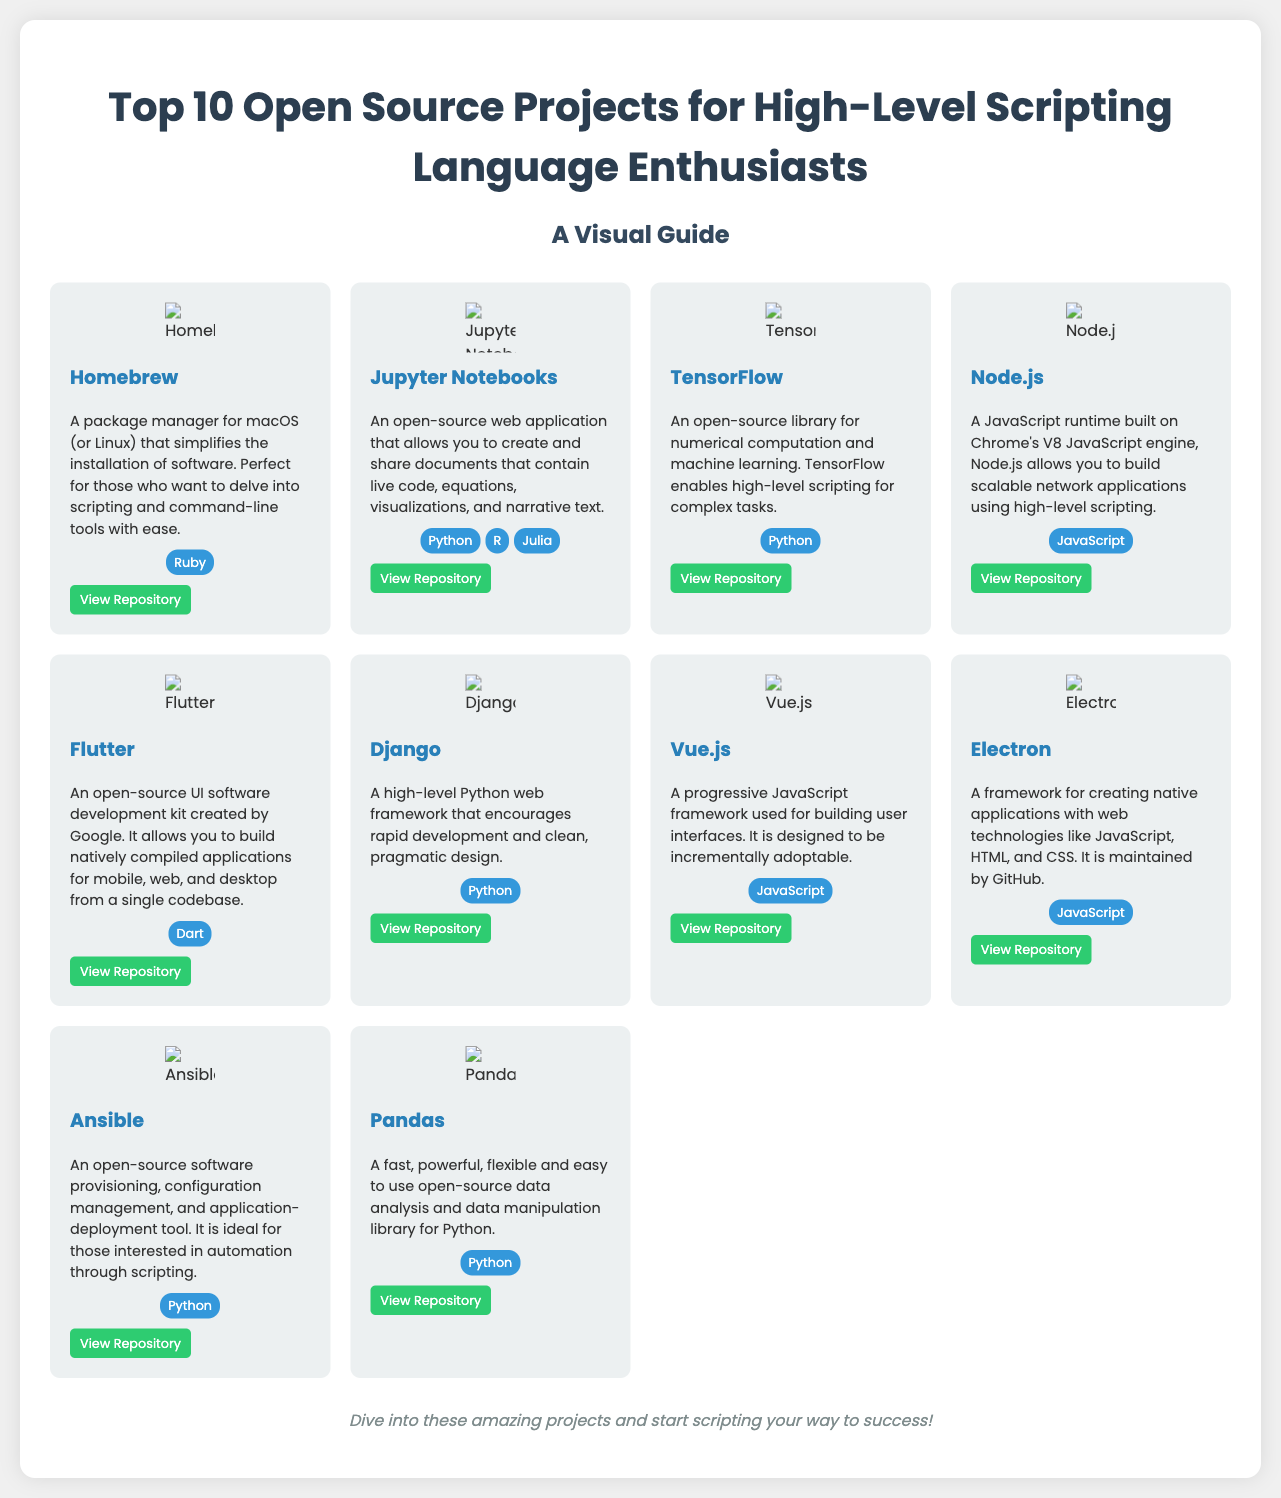What is the title of the poster? The title of the poster is presented prominently at the top of the document, clearly indicating the subject matter.
Answer: Top 10 Open Source Projects for High-Level Scripting Language Enthusiasts How many projects are listed in the document? The document features a grid section that contains the details of projects, and each unique project contributes to the total count.
Answer: 10 Which project is related to data analysis? The descriptions provided for each project include specific domains, and this project is explicitly identified as a data analysis tool.
Answer: Pandas What languages are associated with TensorFlow? The listed programming languages for each project help categorize them, and TensorFlow's specific association is included in its section.
Answer: Python Which project is known for web technologies? This project's description emphasizes its capability of creating native applications utilizing web technologies.
Answer: Electron What software does Homebrew serve as a manager for? The provided details about Homebrew specify the type of software it simplifies installation for, making this information readily available.
Answer: macOS (or Linux) Which framework is designed for rapid web development? The description of each project outlines their purposes, and this particular framework is known specifically for facilitating rapid development.
Answer: Django What is the primary language used in Jupyter Notebooks? The languages listed for each project are important identifiers, and Jupyter Notebooks explicitly states its best-known language.
Answer: Python Which project is maintained by GitHub? Among the descriptions, this project is clearly stated to be maintained by GitHub, providing a key identifying detail.
Answer: Electron 